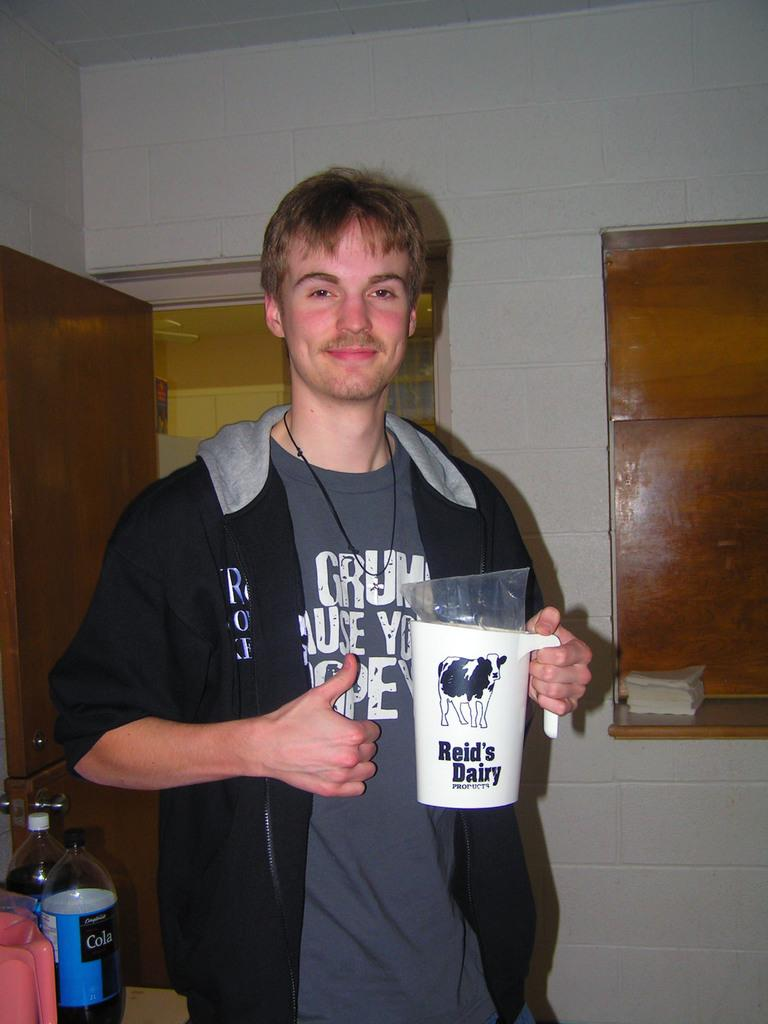Who is in the image? There is a boy in the image. What is the boy holding? The boy is holding a milk jar. What can be seen in the background of the image? There is a white color brick wall, a brown color window, and a brown color door in the background. What other items are visible in the image besides the boy and the milk jar? There are two empty bottles and a pink color jug in the image. What type of organization does the fowl belong to in the image? There is no fowl present in the image. What sound does the alarm make in the image? There is no alarm present in the image. 